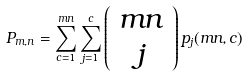<formula> <loc_0><loc_0><loc_500><loc_500>P _ { m , n } = \sum _ { c = 1 } ^ { m n } \sum _ { j = 1 } ^ { c } \left ( \begin{array} { c } m n \\ j \end{array} \right ) p _ { j } ( m n , c )</formula> 